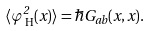Convert formula to latex. <formula><loc_0><loc_0><loc_500><loc_500>\langle \varphi _ { \text { H} } ^ { 2 } ( x ) \rangle = \hbar { G } _ { a b } ( x , x ) .</formula> 